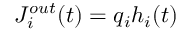Convert formula to latex. <formula><loc_0><loc_0><loc_500><loc_500>J _ { i } ^ { o u t } ( t ) = q _ { i } h _ { i } ( t )</formula> 